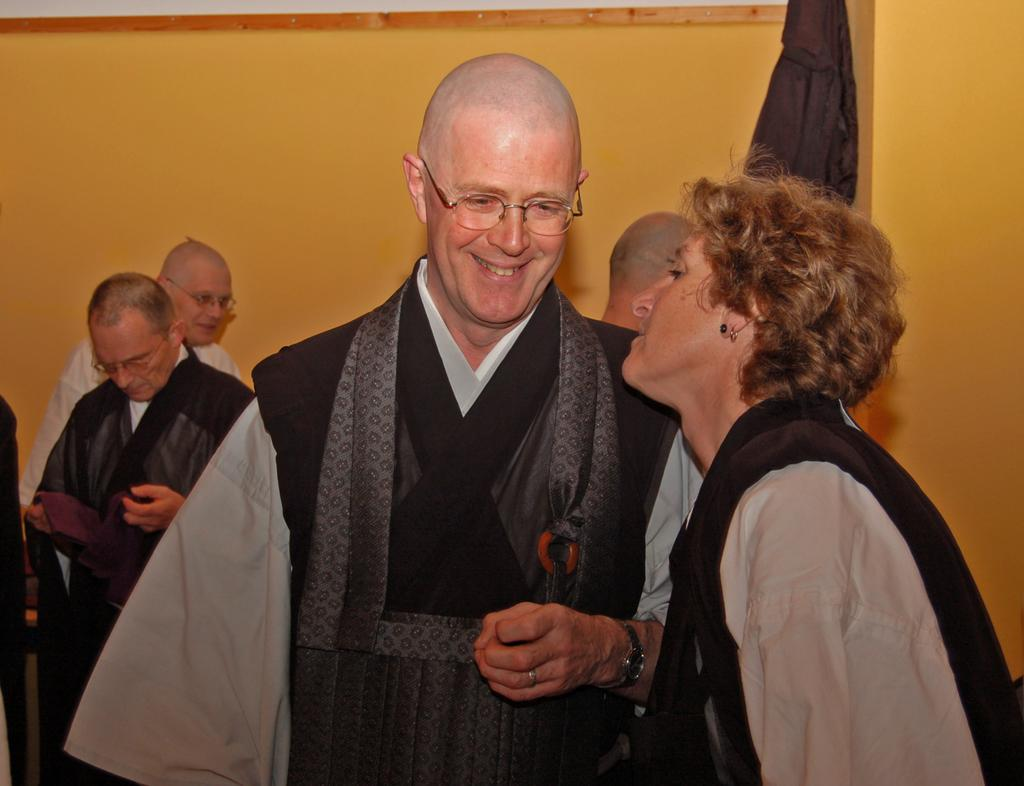How many people are present in the image? There are many people in the image. Can you describe any accessories that some people are wearing? Some people are wearing glasses (specs) in the image. What can be seen in the background of the image? There is a wall in the background of the image. Are there any accessories visible on the people's hands? Yes, one person is wearing a watch, and another person is wearing a ring. What type of jar can be seen on the person's head in the image? There is no jar present on anyone's head in the image. What color is the ink used by the person holding a pen in the image? There is no person holding a pen or using ink in the image. 